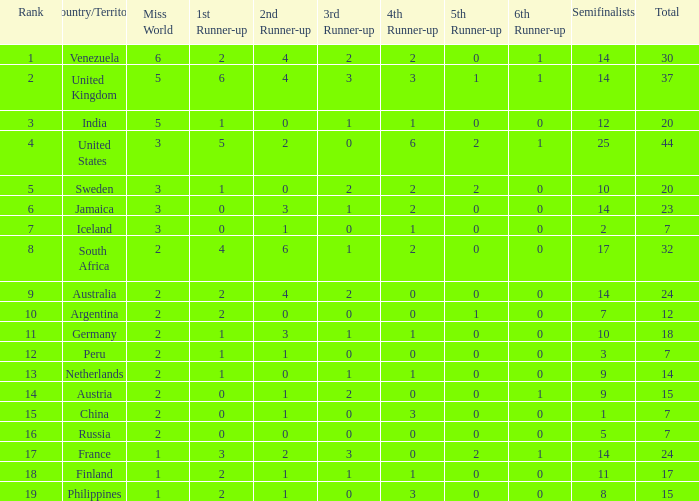What is Venezuela's total rank? 30.0. 